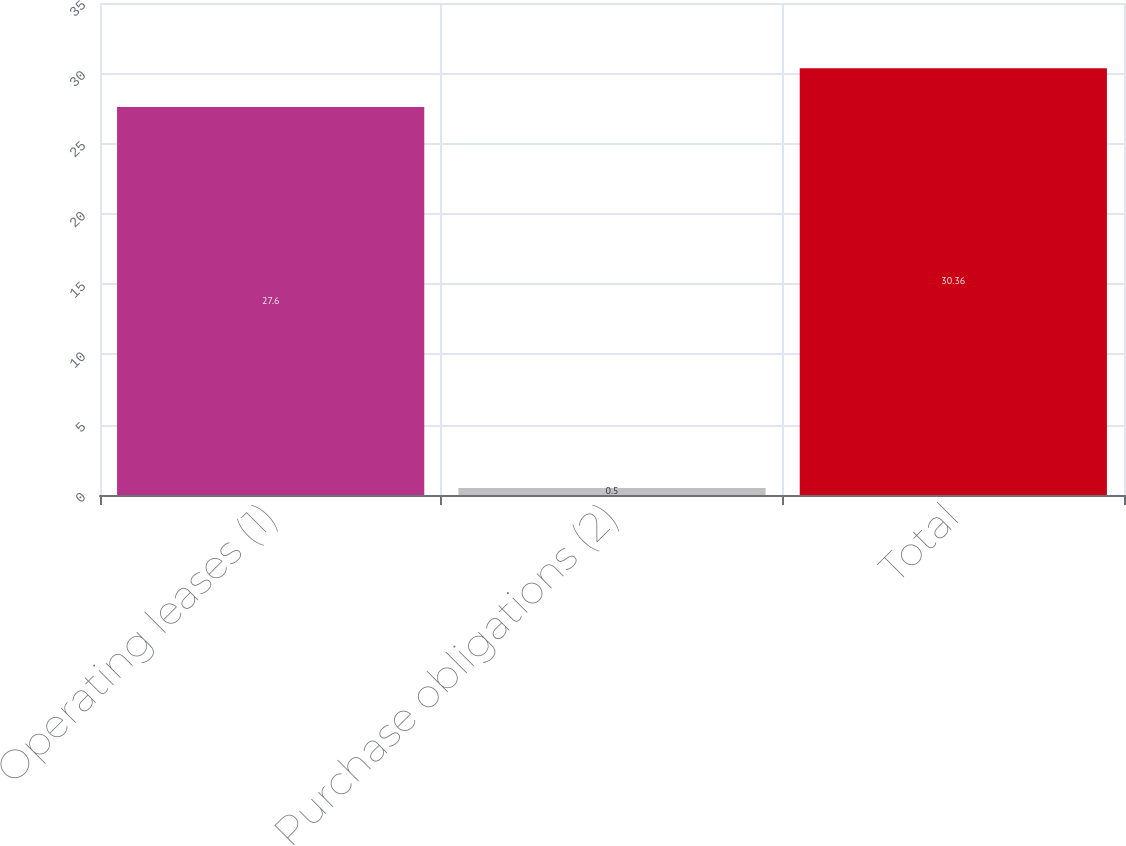<chart> <loc_0><loc_0><loc_500><loc_500><bar_chart><fcel>Operating leases (1)<fcel>Purchase obligations (2)<fcel>Total<nl><fcel>27.6<fcel>0.5<fcel>30.36<nl></chart> 